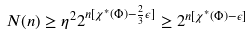<formula> <loc_0><loc_0><loc_500><loc_500>N ( n ) \geq \eta ^ { 2 } 2 ^ { n [ \chi ^ { * } ( \Phi ) - \frac { 2 } { 3 } \epsilon ] } \geq 2 ^ { n [ \chi ^ { * } ( \Phi ) - \epsilon ] }</formula> 